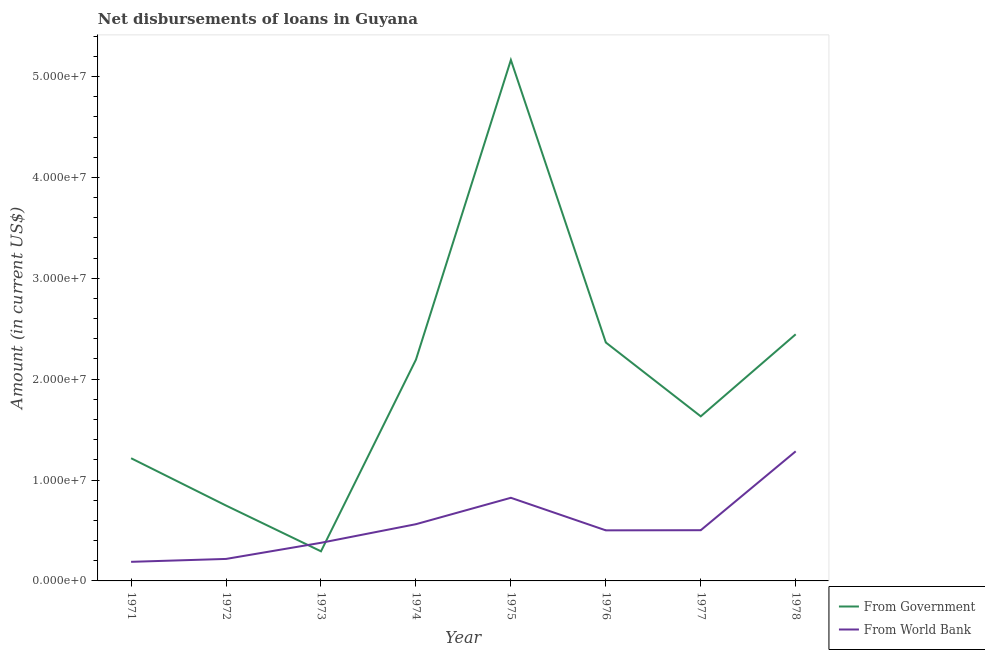Is the number of lines equal to the number of legend labels?
Your answer should be compact. Yes. What is the net disbursements of loan from world bank in 1977?
Provide a short and direct response. 5.03e+06. Across all years, what is the maximum net disbursements of loan from world bank?
Your answer should be compact. 1.28e+07. Across all years, what is the minimum net disbursements of loan from world bank?
Keep it short and to the point. 1.89e+06. In which year was the net disbursements of loan from government maximum?
Offer a very short reply. 1975. What is the total net disbursements of loan from world bank in the graph?
Offer a terse response. 4.46e+07. What is the difference between the net disbursements of loan from government in 1973 and that in 1977?
Provide a succinct answer. -1.34e+07. What is the difference between the net disbursements of loan from world bank in 1975 and the net disbursements of loan from government in 1977?
Keep it short and to the point. -8.07e+06. What is the average net disbursements of loan from world bank per year?
Give a very brief answer. 5.58e+06. In the year 1977, what is the difference between the net disbursements of loan from world bank and net disbursements of loan from government?
Offer a terse response. -1.13e+07. In how many years, is the net disbursements of loan from world bank greater than 50000000 US$?
Ensure brevity in your answer.  0. What is the ratio of the net disbursements of loan from government in 1971 to that in 1978?
Keep it short and to the point. 0.5. Is the net disbursements of loan from world bank in 1971 less than that in 1975?
Offer a very short reply. Yes. Is the difference between the net disbursements of loan from world bank in 1976 and 1978 greater than the difference between the net disbursements of loan from government in 1976 and 1978?
Keep it short and to the point. No. What is the difference between the highest and the second highest net disbursements of loan from world bank?
Your response must be concise. 4.61e+06. What is the difference between the highest and the lowest net disbursements of loan from government?
Provide a succinct answer. 4.87e+07. In how many years, is the net disbursements of loan from world bank greater than the average net disbursements of loan from world bank taken over all years?
Give a very brief answer. 3. Does the net disbursements of loan from government monotonically increase over the years?
Your answer should be compact. No. Is the net disbursements of loan from world bank strictly less than the net disbursements of loan from government over the years?
Give a very brief answer. No. How many years are there in the graph?
Your response must be concise. 8. What is the difference between two consecutive major ticks on the Y-axis?
Your answer should be compact. 1.00e+07. Does the graph contain any zero values?
Your answer should be compact. No. Does the graph contain grids?
Provide a short and direct response. No. Where does the legend appear in the graph?
Offer a terse response. Bottom right. How many legend labels are there?
Your response must be concise. 2. What is the title of the graph?
Provide a succinct answer. Net disbursements of loans in Guyana. What is the Amount (in current US$) in From Government in 1971?
Your answer should be very brief. 1.22e+07. What is the Amount (in current US$) of From World Bank in 1971?
Offer a terse response. 1.89e+06. What is the Amount (in current US$) in From Government in 1972?
Your response must be concise. 7.47e+06. What is the Amount (in current US$) of From World Bank in 1972?
Your answer should be very brief. 2.18e+06. What is the Amount (in current US$) in From Government in 1973?
Offer a terse response. 2.94e+06. What is the Amount (in current US$) in From World Bank in 1973?
Offer a terse response. 3.78e+06. What is the Amount (in current US$) of From Government in 1974?
Give a very brief answer. 2.19e+07. What is the Amount (in current US$) of From World Bank in 1974?
Make the answer very short. 5.62e+06. What is the Amount (in current US$) in From Government in 1975?
Give a very brief answer. 5.16e+07. What is the Amount (in current US$) in From World Bank in 1975?
Your response must be concise. 8.24e+06. What is the Amount (in current US$) in From Government in 1976?
Provide a short and direct response. 2.36e+07. What is the Amount (in current US$) in From World Bank in 1976?
Your answer should be compact. 5.01e+06. What is the Amount (in current US$) of From Government in 1977?
Your answer should be compact. 1.63e+07. What is the Amount (in current US$) in From World Bank in 1977?
Provide a short and direct response. 5.03e+06. What is the Amount (in current US$) of From Government in 1978?
Make the answer very short. 2.44e+07. What is the Amount (in current US$) in From World Bank in 1978?
Your response must be concise. 1.28e+07. Across all years, what is the maximum Amount (in current US$) of From Government?
Provide a succinct answer. 5.16e+07. Across all years, what is the maximum Amount (in current US$) of From World Bank?
Offer a very short reply. 1.28e+07. Across all years, what is the minimum Amount (in current US$) of From Government?
Keep it short and to the point. 2.94e+06. Across all years, what is the minimum Amount (in current US$) of From World Bank?
Provide a succinct answer. 1.89e+06. What is the total Amount (in current US$) in From Government in the graph?
Give a very brief answer. 1.61e+08. What is the total Amount (in current US$) of From World Bank in the graph?
Make the answer very short. 4.46e+07. What is the difference between the Amount (in current US$) in From Government in 1971 and that in 1972?
Your response must be concise. 4.69e+06. What is the difference between the Amount (in current US$) in From World Bank in 1971 and that in 1972?
Offer a very short reply. -2.87e+05. What is the difference between the Amount (in current US$) of From Government in 1971 and that in 1973?
Keep it short and to the point. 9.23e+06. What is the difference between the Amount (in current US$) in From World Bank in 1971 and that in 1973?
Your response must be concise. -1.89e+06. What is the difference between the Amount (in current US$) of From Government in 1971 and that in 1974?
Your answer should be compact. -9.77e+06. What is the difference between the Amount (in current US$) in From World Bank in 1971 and that in 1974?
Offer a terse response. -3.73e+06. What is the difference between the Amount (in current US$) of From Government in 1971 and that in 1975?
Keep it short and to the point. -3.95e+07. What is the difference between the Amount (in current US$) of From World Bank in 1971 and that in 1975?
Your answer should be compact. -6.35e+06. What is the difference between the Amount (in current US$) of From Government in 1971 and that in 1976?
Your answer should be very brief. -1.15e+07. What is the difference between the Amount (in current US$) in From World Bank in 1971 and that in 1976?
Provide a succinct answer. -3.12e+06. What is the difference between the Amount (in current US$) in From Government in 1971 and that in 1977?
Your answer should be very brief. -4.15e+06. What is the difference between the Amount (in current US$) of From World Bank in 1971 and that in 1977?
Your response must be concise. -3.13e+06. What is the difference between the Amount (in current US$) in From Government in 1971 and that in 1978?
Offer a very short reply. -1.23e+07. What is the difference between the Amount (in current US$) in From World Bank in 1971 and that in 1978?
Provide a short and direct response. -1.10e+07. What is the difference between the Amount (in current US$) in From Government in 1972 and that in 1973?
Your answer should be compact. 4.54e+06. What is the difference between the Amount (in current US$) in From World Bank in 1972 and that in 1973?
Your response must be concise. -1.60e+06. What is the difference between the Amount (in current US$) in From Government in 1972 and that in 1974?
Make the answer very short. -1.45e+07. What is the difference between the Amount (in current US$) in From World Bank in 1972 and that in 1974?
Make the answer very short. -3.44e+06. What is the difference between the Amount (in current US$) in From Government in 1972 and that in 1975?
Ensure brevity in your answer.  -4.42e+07. What is the difference between the Amount (in current US$) in From World Bank in 1972 and that in 1975?
Your response must be concise. -6.06e+06. What is the difference between the Amount (in current US$) of From Government in 1972 and that in 1976?
Provide a short and direct response. -1.62e+07. What is the difference between the Amount (in current US$) of From World Bank in 1972 and that in 1976?
Your response must be concise. -2.83e+06. What is the difference between the Amount (in current US$) of From Government in 1972 and that in 1977?
Provide a succinct answer. -8.84e+06. What is the difference between the Amount (in current US$) of From World Bank in 1972 and that in 1977?
Your answer should be very brief. -2.85e+06. What is the difference between the Amount (in current US$) of From Government in 1972 and that in 1978?
Keep it short and to the point. -1.70e+07. What is the difference between the Amount (in current US$) in From World Bank in 1972 and that in 1978?
Make the answer very short. -1.07e+07. What is the difference between the Amount (in current US$) in From Government in 1973 and that in 1974?
Ensure brevity in your answer.  -1.90e+07. What is the difference between the Amount (in current US$) of From World Bank in 1973 and that in 1974?
Your response must be concise. -1.84e+06. What is the difference between the Amount (in current US$) in From Government in 1973 and that in 1975?
Ensure brevity in your answer.  -4.87e+07. What is the difference between the Amount (in current US$) in From World Bank in 1973 and that in 1975?
Give a very brief answer. -4.46e+06. What is the difference between the Amount (in current US$) of From Government in 1973 and that in 1976?
Keep it short and to the point. -2.07e+07. What is the difference between the Amount (in current US$) of From World Bank in 1973 and that in 1976?
Give a very brief answer. -1.23e+06. What is the difference between the Amount (in current US$) of From Government in 1973 and that in 1977?
Make the answer very short. -1.34e+07. What is the difference between the Amount (in current US$) of From World Bank in 1973 and that in 1977?
Provide a short and direct response. -1.25e+06. What is the difference between the Amount (in current US$) in From Government in 1973 and that in 1978?
Your answer should be compact. -2.15e+07. What is the difference between the Amount (in current US$) of From World Bank in 1973 and that in 1978?
Ensure brevity in your answer.  -9.07e+06. What is the difference between the Amount (in current US$) of From Government in 1974 and that in 1975?
Provide a short and direct response. -2.97e+07. What is the difference between the Amount (in current US$) of From World Bank in 1974 and that in 1975?
Give a very brief answer. -2.62e+06. What is the difference between the Amount (in current US$) in From Government in 1974 and that in 1976?
Ensure brevity in your answer.  -1.71e+06. What is the difference between the Amount (in current US$) in From World Bank in 1974 and that in 1976?
Your response must be concise. 6.10e+05. What is the difference between the Amount (in current US$) in From Government in 1974 and that in 1977?
Provide a short and direct response. 5.62e+06. What is the difference between the Amount (in current US$) of From World Bank in 1974 and that in 1977?
Keep it short and to the point. 5.96e+05. What is the difference between the Amount (in current US$) in From Government in 1974 and that in 1978?
Ensure brevity in your answer.  -2.52e+06. What is the difference between the Amount (in current US$) in From World Bank in 1974 and that in 1978?
Keep it short and to the point. -7.22e+06. What is the difference between the Amount (in current US$) in From Government in 1975 and that in 1976?
Your answer should be compact. 2.80e+07. What is the difference between the Amount (in current US$) of From World Bank in 1975 and that in 1976?
Offer a terse response. 3.23e+06. What is the difference between the Amount (in current US$) in From Government in 1975 and that in 1977?
Offer a very short reply. 3.53e+07. What is the difference between the Amount (in current US$) of From World Bank in 1975 and that in 1977?
Your answer should be very brief. 3.21e+06. What is the difference between the Amount (in current US$) in From Government in 1975 and that in 1978?
Your answer should be compact. 2.72e+07. What is the difference between the Amount (in current US$) in From World Bank in 1975 and that in 1978?
Your answer should be very brief. -4.61e+06. What is the difference between the Amount (in current US$) of From Government in 1976 and that in 1977?
Your answer should be compact. 7.32e+06. What is the difference between the Amount (in current US$) of From World Bank in 1976 and that in 1977?
Provide a succinct answer. -1.40e+04. What is the difference between the Amount (in current US$) of From Government in 1976 and that in 1978?
Give a very brief answer. -8.11e+05. What is the difference between the Amount (in current US$) of From World Bank in 1976 and that in 1978?
Your answer should be very brief. -7.83e+06. What is the difference between the Amount (in current US$) of From Government in 1977 and that in 1978?
Make the answer very short. -8.13e+06. What is the difference between the Amount (in current US$) in From World Bank in 1977 and that in 1978?
Ensure brevity in your answer.  -7.82e+06. What is the difference between the Amount (in current US$) of From Government in 1971 and the Amount (in current US$) of From World Bank in 1972?
Your response must be concise. 9.98e+06. What is the difference between the Amount (in current US$) in From Government in 1971 and the Amount (in current US$) in From World Bank in 1973?
Your answer should be very brief. 8.38e+06. What is the difference between the Amount (in current US$) of From Government in 1971 and the Amount (in current US$) of From World Bank in 1974?
Make the answer very short. 6.54e+06. What is the difference between the Amount (in current US$) in From Government in 1971 and the Amount (in current US$) in From World Bank in 1975?
Make the answer very short. 3.92e+06. What is the difference between the Amount (in current US$) of From Government in 1971 and the Amount (in current US$) of From World Bank in 1976?
Ensure brevity in your answer.  7.15e+06. What is the difference between the Amount (in current US$) in From Government in 1971 and the Amount (in current US$) in From World Bank in 1977?
Your response must be concise. 7.14e+06. What is the difference between the Amount (in current US$) in From Government in 1971 and the Amount (in current US$) in From World Bank in 1978?
Your answer should be very brief. -6.85e+05. What is the difference between the Amount (in current US$) of From Government in 1972 and the Amount (in current US$) of From World Bank in 1973?
Provide a short and direct response. 3.69e+06. What is the difference between the Amount (in current US$) of From Government in 1972 and the Amount (in current US$) of From World Bank in 1974?
Ensure brevity in your answer.  1.85e+06. What is the difference between the Amount (in current US$) of From Government in 1972 and the Amount (in current US$) of From World Bank in 1975?
Ensure brevity in your answer.  -7.70e+05. What is the difference between the Amount (in current US$) of From Government in 1972 and the Amount (in current US$) of From World Bank in 1976?
Keep it short and to the point. 2.46e+06. What is the difference between the Amount (in current US$) of From Government in 1972 and the Amount (in current US$) of From World Bank in 1977?
Keep it short and to the point. 2.44e+06. What is the difference between the Amount (in current US$) of From Government in 1972 and the Amount (in current US$) of From World Bank in 1978?
Make the answer very short. -5.38e+06. What is the difference between the Amount (in current US$) of From Government in 1973 and the Amount (in current US$) of From World Bank in 1974?
Keep it short and to the point. -2.69e+06. What is the difference between the Amount (in current US$) of From Government in 1973 and the Amount (in current US$) of From World Bank in 1975?
Offer a terse response. -5.31e+06. What is the difference between the Amount (in current US$) of From Government in 1973 and the Amount (in current US$) of From World Bank in 1976?
Offer a very short reply. -2.08e+06. What is the difference between the Amount (in current US$) of From Government in 1973 and the Amount (in current US$) of From World Bank in 1977?
Your answer should be very brief. -2.09e+06. What is the difference between the Amount (in current US$) of From Government in 1973 and the Amount (in current US$) of From World Bank in 1978?
Give a very brief answer. -9.91e+06. What is the difference between the Amount (in current US$) in From Government in 1974 and the Amount (in current US$) in From World Bank in 1975?
Offer a very short reply. 1.37e+07. What is the difference between the Amount (in current US$) in From Government in 1974 and the Amount (in current US$) in From World Bank in 1976?
Make the answer very short. 1.69e+07. What is the difference between the Amount (in current US$) in From Government in 1974 and the Amount (in current US$) in From World Bank in 1977?
Ensure brevity in your answer.  1.69e+07. What is the difference between the Amount (in current US$) in From Government in 1974 and the Amount (in current US$) in From World Bank in 1978?
Your response must be concise. 9.08e+06. What is the difference between the Amount (in current US$) of From Government in 1975 and the Amount (in current US$) of From World Bank in 1976?
Ensure brevity in your answer.  4.66e+07. What is the difference between the Amount (in current US$) in From Government in 1975 and the Amount (in current US$) in From World Bank in 1977?
Offer a terse response. 4.66e+07. What is the difference between the Amount (in current US$) in From Government in 1975 and the Amount (in current US$) in From World Bank in 1978?
Your response must be concise. 3.88e+07. What is the difference between the Amount (in current US$) of From Government in 1976 and the Amount (in current US$) of From World Bank in 1977?
Offer a very short reply. 1.86e+07. What is the difference between the Amount (in current US$) of From Government in 1976 and the Amount (in current US$) of From World Bank in 1978?
Provide a short and direct response. 1.08e+07. What is the difference between the Amount (in current US$) of From Government in 1977 and the Amount (in current US$) of From World Bank in 1978?
Provide a short and direct response. 3.47e+06. What is the average Amount (in current US$) of From Government per year?
Your answer should be compact. 2.01e+07. What is the average Amount (in current US$) of From World Bank per year?
Provide a short and direct response. 5.58e+06. In the year 1971, what is the difference between the Amount (in current US$) in From Government and Amount (in current US$) in From World Bank?
Make the answer very short. 1.03e+07. In the year 1972, what is the difference between the Amount (in current US$) in From Government and Amount (in current US$) in From World Bank?
Offer a very short reply. 5.29e+06. In the year 1973, what is the difference between the Amount (in current US$) of From Government and Amount (in current US$) of From World Bank?
Make the answer very short. -8.44e+05. In the year 1974, what is the difference between the Amount (in current US$) in From Government and Amount (in current US$) in From World Bank?
Ensure brevity in your answer.  1.63e+07. In the year 1975, what is the difference between the Amount (in current US$) in From Government and Amount (in current US$) in From World Bank?
Keep it short and to the point. 4.34e+07. In the year 1976, what is the difference between the Amount (in current US$) of From Government and Amount (in current US$) of From World Bank?
Your response must be concise. 1.86e+07. In the year 1977, what is the difference between the Amount (in current US$) of From Government and Amount (in current US$) of From World Bank?
Offer a very short reply. 1.13e+07. In the year 1978, what is the difference between the Amount (in current US$) in From Government and Amount (in current US$) in From World Bank?
Provide a succinct answer. 1.16e+07. What is the ratio of the Amount (in current US$) in From Government in 1971 to that in 1972?
Your response must be concise. 1.63. What is the ratio of the Amount (in current US$) in From World Bank in 1971 to that in 1972?
Your answer should be very brief. 0.87. What is the ratio of the Amount (in current US$) in From Government in 1971 to that in 1973?
Ensure brevity in your answer.  4.14. What is the ratio of the Amount (in current US$) in From World Bank in 1971 to that in 1973?
Your response must be concise. 0.5. What is the ratio of the Amount (in current US$) in From Government in 1971 to that in 1974?
Your answer should be compact. 0.55. What is the ratio of the Amount (in current US$) in From World Bank in 1971 to that in 1974?
Your answer should be compact. 0.34. What is the ratio of the Amount (in current US$) in From Government in 1971 to that in 1975?
Your answer should be very brief. 0.24. What is the ratio of the Amount (in current US$) of From World Bank in 1971 to that in 1975?
Give a very brief answer. 0.23. What is the ratio of the Amount (in current US$) of From Government in 1971 to that in 1976?
Ensure brevity in your answer.  0.51. What is the ratio of the Amount (in current US$) of From World Bank in 1971 to that in 1976?
Your answer should be very brief. 0.38. What is the ratio of the Amount (in current US$) of From Government in 1971 to that in 1977?
Provide a succinct answer. 0.75. What is the ratio of the Amount (in current US$) in From World Bank in 1971 to that in 1977?
Ensure brevity in your answer.  0.38. What is the ratio of the Amount (in current US$) of From Government in 1971 to that in 1978?
Offer a terse response. 0.5. What is the ratio of the Amount (in current US$) of From World Bank in 1971 to that in 1978?
Give a very brief answer. 0.15. What is the ratio of the Amount (in current US$) of From Government in 1972 to that in 1973?
Offer a terse response. 2.55. What is the ratio of the Amount (in current US$) of From World Bank in 1972 to that in 1973?
Give a very brief answer. 0.58. What is the ratio of the Amount (in current US$) of From Government in 1972 to that in 1974?
Your answer should be very brief. 0.34. What is the ratio of the Amount (in current US$) of From World Bank in 1972 to that in 1974?
Offer a terse response. 0.39. What is the ratio of the Amount (in current US$) in From Government in 1972 to that in 1975?
Your answer should be very brief. 0.14. What is the ratio of the Amount (in current US$) of From World Bank in 1972 to that in 1975?
Your answer should be very brief. 0.26. What is the ratio of the Amount (in current US$) of From Government in 1972 to that in 1976?
Keep it short and to the point. 0.32. What is the ratio of the Amount (in current US$) of From World Bank in 1972 to that in 1976?
Make the answer very short. 0.43. What is the ratio of the Amount (in current US$) of From Government in 1972 to that in 1977?
Provide a short and direct response. 0.46. What is the ratio of the Amount (in current US$) in From World Bank in 1972 to that in 1977?
Make the answer very short. 0.43. What is the ratio of the Amount (in current US$) of From Government in 1972 to that in 1978?
Your answer should be very brief. 0.31. What is the ratio of the Amount (in current US$) in From World Bank in 1972 to that in 1978?
Provide a short and direct response. 0.17. What is the ratio of the Amount (in current US$) in From Government in 1973 to that in 1974?
Keep it short and to the point. 0.13. What is the ratio of the Amount (in current US$) of From World Bank in 1973 to that in 1974?
Keep it short and to the point. 0.67. What is the ratio of the Amount (in current US$) of From Government in 1973 to that in 1975?
Provide a succinct answer. 0.06. What is the ratio of the Amount (in current US$) of From World Bank in 1973 to that in 1975?
Offer a very short reply. 0.46. What is the ratio of the Amount (in current US$) in From Government in 1973 to that in 1976?
Ensure brevity in your answer.  0.12. What is the ratio of the Amount (in current US$) in From World Bank in 1973 to that in 1976?
Your answer should be compact. 0.75. What is the ratio of the Amount (in current US$) in From Government in 1973 to that in 1977?
Offer a terse response. 0.18. What is the ratio of the Amount (in current US$) of From World Bank in 1973 to that in 1977?
Make the answer very short. 0.75. What is the ratio of the Amount (in current US$) in From Government in 1973 to that in 1978?
Make the answer very short. 0.12. What is the ratio of the Amount (in current US$) in From World Bank in 1973 to that in 1978?
Your response must be concise. 0.29. What is the ratio of the Amount (in current US$) in From Government in 1974 to that in 1975?
Offer a terse response. 0.42. What is the ratio of the Amount (in current US$) in From World Bank in 1974 to that in 1975?
Keep it short and to the point. 0.68. What is the ratio of the Amount (in current US$) of From Government in 1974 to that in 1976?
Give a very brief answer. 0.93. What is the ratio of the Amount (in current US$) in From World Bank in 1974 to that in 1976?
Give a very brief answer. 1.12. What is the ratio of the Amount (in current US$) of From Government in 1974 to that in 1977?
Offer a terse response. 1.34. What is the ratio of the Amount (in current US$) in From World Bank in 1974 to that in 1977?
Your answer should be compact. 1.12. What is the ratio of the Amount (in current US$) in From Government in 1974 to that in 1978?
Your answer should be very brief. 0.9. What is the ratio of the Amount (in current US$) of From World Bank in 1974 to that in 1978?
Offer a very short reply. 0.44. What is the ratio of the Amount (in current US$) in From Government in 1975 to that in 1976?
Provide a short and direct response. 2.18. What is the ratio of the Amount (in current US$) in From World Bank in 1975 to that in 1976?
Offer a very short reply. 1.64. What is the ratio of the Amount (in current US$) of From Government in 1975 to that in 1977?
Give a very brief answer. 3.17. What is the ratio of the Amount (in current US$) in From World Bank in 1975 to that in 1977?
Make the answer very short. 1.64. What is the ratio of the Amount (in current US$) in From Government in 1975 to that in 1978?
Your answer should be compact. 2.11. What is the ratio of the Amount (in current US$) in From World Bank in 1975 to that in 1978?
Keep it short and to the point. 0.64. What is the ratio of the Amount (in current US$) of From Government in 1976 to that in 1977?
Provide a succinct answer. 1.45. What is the ratio of the Amount (in current US$) of From Government in 1976 to that in 1978?
Keep it short and to the point. 0.97. What is the ratio of the Amount (in current US$) in From World Bank in 1976 to that in 1978?
Keep it short and to the point. 0.39. What is the ratio of the Amount (in current US$) in From Government in 1977 to that in 1978?
Your answer should be very brief. 0.67. What is the ratio of the Amount (in current US$) in From World Bank in 1977 to that in 1978?
Give a very brief answer. 0.39. What is the difference between the highest and the second highest Amount (in current US$) in From Government?
Provide a succinct answer. 2.72e+07. What is the difference between the highest and the second highest Amount (in current US$) of From World Bank?
Provide a succinct answer. 4.61e+06. What is the difference between the highest and the lowest Amount (in current US$) in From Government?
Ensure brevity in your answer.  4.87e+07. What is the difference between the highest and the lowest Amount (in current US$) of From World Bank?
Make the answer very short. 1.10e+07. 